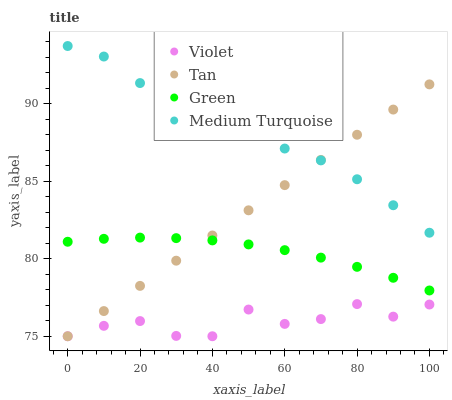Does Violet have the minimum area under the curve?
Answer yes or no. Yes. Does Medium Turquoise have the maximum area under the curve?
Answer yes or no. Yes. Does Green have the minimum area under the curve?
Answer yes or no. No. Does Green have the maximum area under the curve?
Answer yes or no. No. Is Tan the smoothest?
Answer yes or no. Yes. Is Violet the roughest?
Answer yes or no. Yes. Is Green the smoothest?
Answer yes or no. No. Is Green the roughest?
Answer yes or no. No. Does Tan have the lowest value?
Answer yes or no. Yes. Does Green have the lowest value?
Answer yes or no. No. Does Medium Turquoise have the highest value?
Answer yes or no. Yes. Does Green have the highest value?
Answer yes or no. No. Is Violet less than Medium Turquoise?
Answer yes or no. Yes. Is Medium Turquoise greater than Green?
Answer yes or no. Yes. Does Tan intersect Violet?
Answer yes or no. Yes. Is Tan less than Violet?
Answer yes or no. No. Is Tan greater than Violet?
Answer yes or no. No. Does Violet intersect Medium Turquoise?
Answer yes or no. No. 